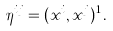Convert formula to latex. <formula><loc_0><loc_0><loc_500><loc_500>\eta ^ { i j } = ( x ^ { i } , x ^ { j } ) ^ { 1 } \, .</formula> 